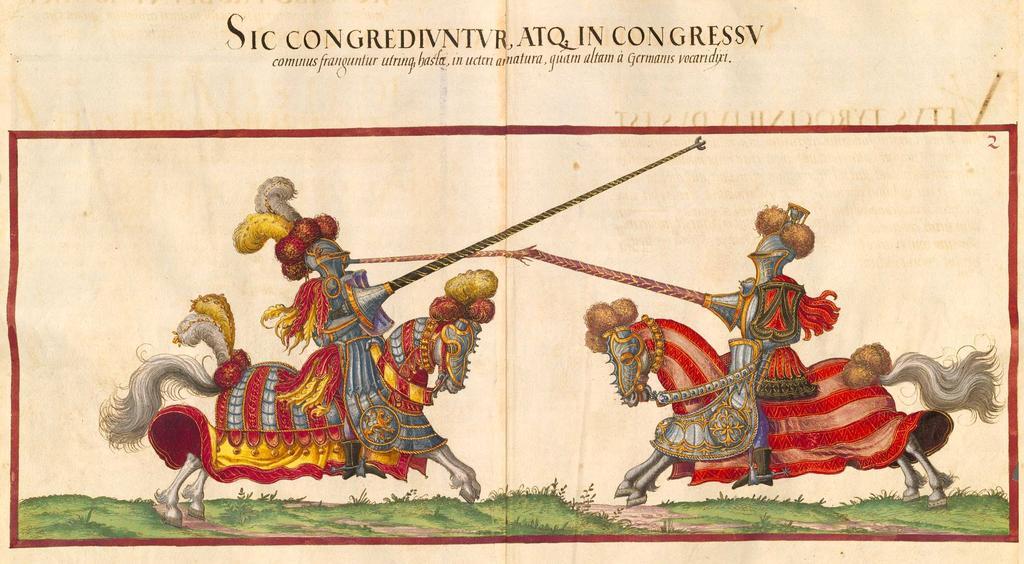Could you give a brief overview of what you see in this image? In this picture we can see an object seems to be the poster on which we can see the pictures of the horses and the pictures of some other objects and we can see the green grass, plants. At the top we can see the text on the image. 